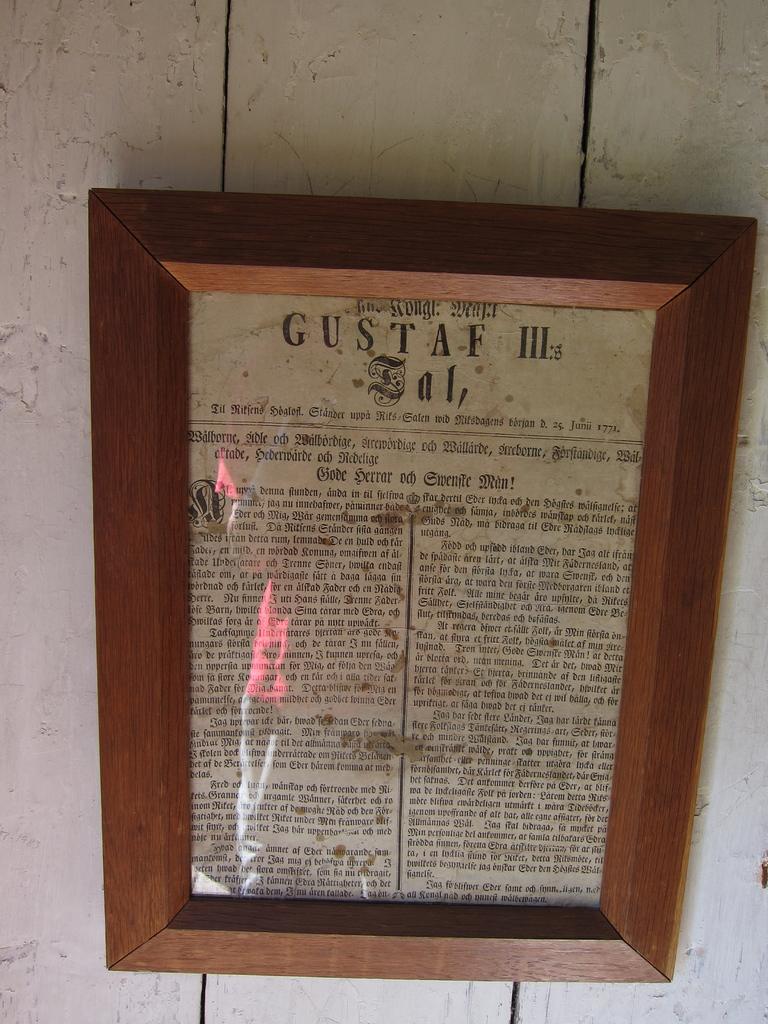Is this a newspaper?
Make the answer very short. Yes. 